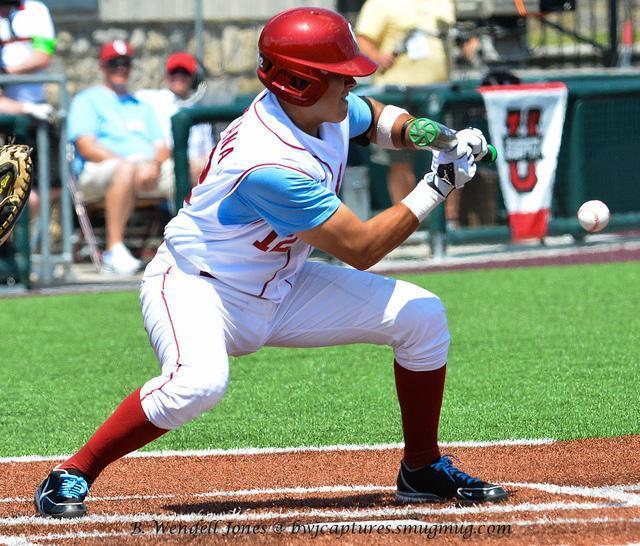How many people are in the photo?
Give a very brief answer. 5. How many baby giraffes are in the field?
Give a very brief answer. 0. 